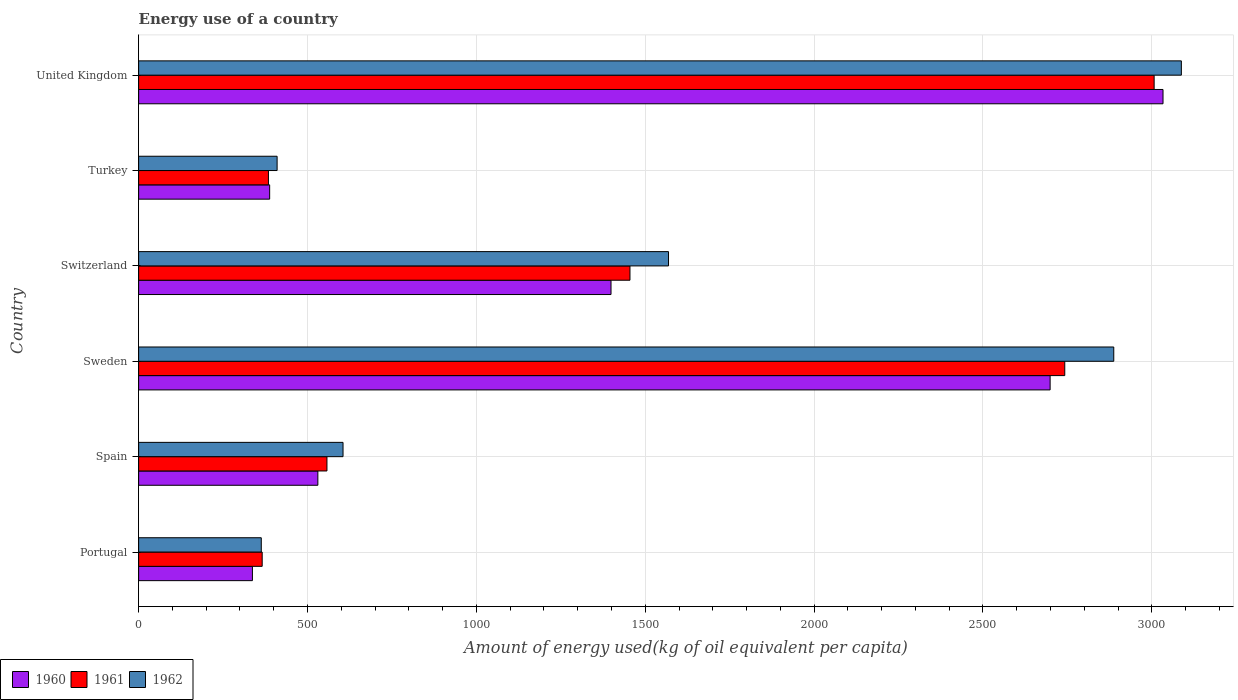How many different coloured bars are there?
Provide a succinct answer. 3. Are the number of bars per tick equal to the number of legend labels?
Provide a short and direct response. Yes. How many bars are there on the 3rd tick from the top?
Your response must be concise. 3. What is the label of the 3rd group of bars from the top?
Ensure brevity in your answer.  Switzerland. What is the amount of energy used in in 1960 in Sweden?
Ensure brevity in your answer.  2698.79. Across all countries, what is the maximum amount of energy used in in 1960?
Make the answer very short. 3033.05. Across all countries, what is the minimum amount of energy used in in 1962?
Give a very brief answer. 363.16. In which country was the amount of energy used in in 1961 maximum?
Your answer should be very brief. United Kingdom. What is the total amount of energy used in in 1961 in the graph?
Offer a terse response. 8511.41. What is the difference between the amount of energy used in in 1960 in Spain and that in Turkey?
Make the answer very short. 142.69. What is the difference between the amount of energy used in in 1961 in Spain and the amount of energy used in in 1962 in Portugal?
Offer a terse response. 194.44. What is the average amount of energy used in in 1962 per country?
Your answer should be very brief. 1486.98. What is the difference between the amount of energy used in in 1960 and amount of energy used in in 1961 in Turkey?
Keep it short and to the point. 3.62. In how many countries, is the amount of energy used in in 1960 greater than 2200 kg?
Your response must be concise. 2. What is the ratio of the amount of energy used in in 1962 in Portugal to that in United Kingdom?
Ensure brevity in your answer.  0.12. What is the difference between the highest and the second highest amount of energy used in in 1960?
Make the answer very short. 334.26. What is the difference between the highest and the lowest amount of energy used in in 1962?
Offer a very short reply. 2724.18. Is the sum of the amount of energy used in in 1960 in Switzerland and Turkey greater than the maximum amount of energy used in in 1962 across all countries?
Your response must be concise. No. What does the 3rd bar from the top in Turkey represents?
Your answer should be compact. 1960. What does the 1st bar from the bottom in United Kingdom represents?
Keep it short and to the point. 1960. Is it the case that in every country, the sum of the amount of energy used in in 1962 and amount of energy used in in 1960 is greater than the amount of energy used in in 1961?
Ensure brevity in your answer.  Yes. Are all the bars in the graph horizontal?
Keep it short and to the point. Yes. How many countries are there in the graph?
Keep it short and to the point. 6. What is the difference between two consecutive major ticks on the X-axis?
Provide a short and direct response. 500. Does the graph contain grids?
Your answer should be compact. Yes. Where does the legend appear in the graph?
Make the answer very short. Bottom left. How many legend labels are there?
Keep it short and to the point. 3. How are the legend labels stacked?
Offer a very short reply. Horizontal. What is the title of the graph?
Your answer should be compact. Energy use of a country. What is the label or title of the X-axis?
Your response must be concise. Amount of energy used(kg of oil equivalent per capita). What is the label or title of the Y-axis?
Make the answer very short. Country. What is the Amount of energy used(kg of oil equivalent per capita) of 1960 in Portugal?
Your response must be concise. 336.91. What is the Amount of energy used(kg of oil equivalent per capita) in 1961 in Portugal?
Your answer should be very brief. 365.84. What is the Amount of energy used(kg of oil equivalent per capita) in 1962 in Portugal?
Provide a succinct answer. 363.16. What is the Amount of energy used(kg of oil equivalent per capita) of 1960 in Spain?
Make the answer very short. 530.66. What is the Amount of energy used(kg of oil equivalent per capita) in 1961 in Spain?
Give a very brief answer. 557.6. What is the Amount of energy used(kg of oil equivalent per capita) of 1962 in Spain?
Give a very brief answer. 605.22. What is the Amount of energy used(kg of oil equivalent per capita) of 1960 in Sweden?
Your answer should be compact. 2698.79. What is the Amount of energy used(kg of oil equivalent per capita) of 1961 in Sweden?
Your answer should be very brief. 2742.12. What is the Amount of energy used(kg of oil equivalent per capita) of 1962 in Sweden?
Provide a short and direct response. 2887.24. What is the Amount of energy used(kg of oil equivalent per capita) of 1960 in Switzerland?
Give a very brief answer. 1398.65. What is the Amount of energy used(kg of oil equivalent per capita) of 1961 in Switzerland?
Offer a very short reply. 1454.76. What is the Amount of energy used(kg of oil equivalent per capita) of 1962 in Switzerland?
Give a very brief answer. 1568.91. What is the Amount of energy used(kg of oil equivalent per capita) of 1960 in Turkey?
Make the answer very short. 387.97. What is the Amount of energy used(kg of oil equivalent per capita) in 1961 in Turkey?
Make the answer very short. 384.35. What is the Amount of energy used(kg of oil equivalent per capita) of 1962 in Turkey?
Offer a very short reply. 410.02. What is the Amount of energy used(kg of oil equivalent per capita) in 1960 in United Kingdom?
Your answer should be compact. 3033.05. What is the Amount of energy used(kg of oil equivalent per capita) of 1961 in United Kingdom?
Provide a short and direct response. 3006.75. What is the Amount of energy used(kg of oil equivalent per capita) of 1962 in United Kingdom?
Make the answer very short. 3087.34. Across all countries, what is the maximum Amount of energy used(kg of oil equivalent per capita) of 1960?
Your response must be concise. 3033.05. Across all countries, what is the maximum Amount of energy used(kg of oil equivalent per capita) of 1961?
Give a very brief answer. 3006.75. Across all countries, what is the maximum Amount of energy used(kg of oil equivalent per capita) of 1962?
Your answer should be compact. 3087.34. Across all countries, what is the minimum Amount of energy used(kg of oil equivalent per capita) of 1960?
Provide a succinct answer. 336.91. Across all countries, what is the minimum Amount of energy used(kg of oil equivalent per capita) in 1961?
Offer a terse response. 365.84. Across all countries, what is the minimum Amount of energy used(kg of oil equivalent per capita) of 1962?
Offer a terse response. 363.16. What is the total Amount of energy used(kg of oil equivalent per capita) of 1960 in the graph?
Your answer should be compact. 8386.05. What is the total Amount of energy used(kg of oil equivalent per capita) of 1961 in the graph?
Ensure brevity in your answer.  8511.41. What is the total Amount of energy used(kg of oil equivalent per capita) of 1962 in the graph?
Your answer should be very brief. 8921.9. What is the difference between the Amount of energy used(kg of oil equivalent per capita) of 1960 in Portugal and that in Spain?
Give a very brief answer. -193.75. What is the difference between the Amount of energy used(kg of oil equivalent per capita) in 1961 in Portugal and that in Spain?
Keep it short and to the point. -191.76. What is the difference between the Amount of energy used(kg of oil equivalent per capita) of 1962 in Portugal and that in Spain?
Provide a short and direct response. -242.06. What is the difference between the Amount of energy used(kg of oil equivalent per capita) in 1960 in Portugal and that in Sweden?
Your answer should be compact. -2361.88. What is the difference between the Amount of energy used(kg of oil equivalent per capita) in 1961 in Portugal and that in Sweden?
Offer a very short reply. -2376.28. What is the difference between the Amount of energy used(kg of oil equivalent per capita) in 1962 in Portugal and that in Sweden?
Give a very brief answer. -2524.07. What is the difference between the Amount of energy used(kg of oil equivalent per capita) of 1960 in Portugal and that in Switzerland?
Your response must be concise. -1061.74. What is the difference between the Amount of energy used(kg of oil equivalent per capita) in 1961 in Portugal and that in Switzerland?
Give a very brief answer. -1088.91. What is the difference between the Amount of energy used(kg of oil equivalent per capita) in 1962 in Portugal and that in Switzerland?
Give a very brief answer. -1205.75. What is the difference between the Amount of energy used(kg of oil equivalent per capita) in 1960 in Portugal and that in Turkey?
Provide a short and direct response. -51.06. What is the difference between the Amount of energy used(kg of oil equivalent per capita) of 1961 in Portugal and that in Turkey?
Ensure brevity in your answer.  -18.51. What is the difference between the Amount of energy used(kg of oil equivalent per capita) of 1962 in Portugal and that in Turkey?
Provide a succinct answer. -46.86. What is the difference between the Amount of energy used(kg of oil equivalent per capita) of 1960 in Portugal and that in United Kingdom?
Give a very brief answer. -2696.14. What is the difference between the Amount of energy used(kg of oil equivalent per capita) of 1961 in Portugal and that in United Kingdom?
Provide a succinct answer. -2640.91. What is the difference between the Amount of energy used(kg of oil equivalent per capita) of 1962 in Portugal and that in United Kingdom?
Offer a terse response. -2724.18. What is the difference between the Amount of energy used(kg of oil equivalent per capita) in 1960 in Spain and that in Sweden?
Ensure brevity in your answer.  -2168.13. What is the difference between the Amount of energy used(kg of oil equivalent per capita) of 1961 in Spain and that in Sweden?
Make the answer very short. -2184.52. What is the difference between the Amount of energy used(kg of oil equivalent per capita) in 1962 in Spain and that in Sweden?
Ensure brevity in your answer.  -2282.01. What is the difference between the Amount of energy used(kg of oil equivalent per capita) of 1960 in Spain and that in Switzerland?
Your response must be concise. -867.99. What is the difference between the Amount of energy used(kg of oil equivalent per capita) in 1961 in Spain and that in Switzerland?
Provide a succinct answer. -897.16. What is the difference between the Amount of energy used(kg of oil equivalent per capita) of 1962 in Spain and that in Switzerland?
Offer a very short reply. -963.69. What is the difference between the Amount of energy used(kg of oil equivalent per capita) in 1960 in Spain and that in Turkey?
Ensure brevity in your answer.  142.69. What is the difference between the Amount of energy used(kg of oil equivalent per capita) of 1961 in Spain and that in Turkey?
Ensure brevity in your answer.  173.25. What is the difference between the Amount of energy used(kg of oil equivalent per capita) of 1962 in Spain and that in Turkey?
Provide a succinct answer. 195.2. What is the difference between the Amount of energy used(kg of oil equivalent per capita) of 1960 in Spain and that in United Kingdom?
Make the answer very short. -2502.39. What is the difference between the Amount of energy used(kg of oil equivalent per capita) in 1961 in Spain and that in United Kingdom?
Keep it short and to the point. -2449.15. What is the difference between the Amount of energy used(kg of oil equivalent per capita) in 1962 in Spain and that in United Kingdom?
Ensure brevity in your answer.  -2482.12. What is the difference between the Amount of energy used(kg of oil equivalent per capita) of 1960 in Sweden and that in Switzerland?
Give a very brief answer. 1300.14. What is the difference between the Amount of energy used(kg of oil equivalent per capita) in 1961 in Sweden and that in Switzerland?
Your response must be concise. 1287.37. What is the difference between the Amount of energy used(kg of oil equivalent per capita) of 1962 in Sweden and that in Switzerland?
Offer a very short reply. 1318.33. What is the difference between the Amount of energy used(kg of oil equivalent per capita) of 1960 in Sweden and that in Turkey?
Your response must be concise. 2310.82. What is the difference between the Amount of energy used(kg of oil equivalent per capita) of 1961 in Sweden and that in Turkey?
Provide a succinct answer. 2357.78. What is the difference between the Amount of energy used(kg of oil equivalent per capita) of 1962 in Sweden and that in Turkey?
Your answer should be very brief. 2477.21. What is the difference between the Amount of energy used(kg of oil equivalent per capita) in 1960 in Sweden and that in United Kingdom?
Offer a very short reply. -334.26. What is the difference between the Amount of energy used(kg of oil equivalent per capita) of 1961 in Sweden and that in United Kingdom?
Provide a short and direct response. -264.62. What is the difference between the Amount of energy used(kg of oil equivalent per capita) in 1962 in Sweden and that in United Kingdom?
Offer a very short reply. -200.11. What is the difference between the Amount of energy used(kg of oil equivalent per capita) of 1960 in Switzerland and that in Turkey?
Your answer should be compact. 1010.68. What is the difference between the Amount of energy used(kg of oil equivalent per capita) in 1961 in Switzerland and that in Turkey?
Offer a terse response. 1070.41. What is the difference between the Amount of energy used(kg of oil equivalent per capita) in 1962 in Switzerland and that in Turkey?
Your answer should be very brief. 1158.89. What is the difference between the Amount of energy used(kg of oil equivalent per capita) of 1960 in Switzerland and that in United Kingdom?
Your answer should be compact. -1634.4. What is the difference between the Amount of energy used(kg of oil equivalent per capita) in 1961 in Switzerland and that in United Kingdom?
Ensure brevity in your answer.  -1551.99. What is the difference between the Amount of energy used(kg of oil equivalent per capita) of 1962 in Switzerland and that in United Kingdom?
Offer a terse response. -1518.43. What is the difference between the Amount of energy used(kg of oil equivalent per capita) of 1960 in Turkey and that in United Kingdom?
Offer a very short reply. -2645.08. What is the difference between the Amount of energy used(kg of oil equivalent per capita) of 1961 in Turkey and that in United Kingdom?
Make the answer very short. -2622.4. What is the difference between the Amount of energy used(kg of oil equivalent per capita) of 1962 in Turkey and that in United Kingdom?
Give a very brief answer. -2677.32. What is the difference between the Amount of energy used(kg of oil equivalent per capita) in 1960 in Portugal and the Amount of energy used(kg of oil equivalent per capita) in 1961 in Spain?
Offer a very short reply. -220.69. What is the difference between the Amount of energy used(kg of oil equivalent per capita) in 1960 in Portugal and the Amount of energy used(kg of oil equivalent per capita) in 1962 in Spain?
Make the answer very short. -268.31. What is the difference between the Amount of energy used(kg of oil equivalent per capita) of 1961 in Portugal and the Amount of energy used(kg of oil equivalent per capita) of 1962 in Spain?
Ensure brevity in your answer.  -239.38. What is the difference between the Amount of energy used(kg of oil equivalent per capita) of 1960 in Portugal and the Amount of energy used(kg of oil equivalent per capita) of 1961 in Sweden?
Your answer should be compact. -2405.21. What is the difference between the Amount of energy used(kg of oil equivalent per capita) in 1960 in Portugal and the Amount of energy used(kg of oil equivalent per capita) in 1962 in Sweden?
Offer a terse response. -2550.32. What is the difference between the Amount of energy used(kg of oil equivalent per capita) of 1961 in Portugal and the Amount of energy used(kg of oil equivalent per capita) of 1962 in Sweden?
Give a very brief answer. -2521.4. What is the difference between the Amount of energy used(kg of oil equivalent per capita) of 1960 in Portugal and the Amount of energy used(kg of oil equivalent per capita) of 1961 in Switzerland?
Make the answer very short. -1117.84. What is the difference between the Amount of energy used(kg of oil equivalent per capita) of 1960 in Portugal and the Amount of energy used(kg of oil equivalent per capita) of 1962 in Switzerland?
Provide a short and direct response. -1232. What is the difference between the Amount of energy used(kg of oil equivalent per capita) of 1961 in Portugal and the Amount of energy used(kg of oil equivalent per capita) of 1962 in Switzerland?
Keep it short and to the point. -1203.07. What is the difference between the Amount of energy used(kg of oil equivalent per capita) in 1960 in Portugal and the Amount of energy used(kg of oil equivalent per capita) in 1961 in Turkey?
Provide a succinct answer. -47.43. What is the difference between the Amount of energy used(kg of oil equivalent per capita) in 1960 in Portugal and the Amount of energy used(kg of oil equivalent per capita) in 1962 in Turkey?
Your response must be concise. -73.11. What is the difference between the Amount of energy used(kg of oil equivalent per capita) in 1961 in Portugal and the Amount of energy used(kg of oil equivalent per capita) in 1962 in Turkey?
Your response must be concise. -44.18. What is the difference between the Amount of energy used(kg of oil equivalent per capita) in 1960 in Portugal and the Amount of energy used(kg of oil equivalent per capita) in 1961 in United Kingdom?
Give a very brief answer. -2669.83. What is the difference between the Amount of energy used(kg of oil equivalent per capita) in 1960 in Portugal and the Amount of energy used(kg of oil equivalent per capita) in 1962 in United Kingdom?
Provide a succinct answer. -2750.43. What is the difference between the Amount of energy used(kg of oil equivalent per capita) of 1961 in Portugal and the Amount of energy used(kg of oil equivalent per capita) of 1962 in United Kingdom?
Provide a succinct answer. -2721.5. What is the difference between the Amount of energy used(kg of oil equivalent per capita) of 1960 in Spain and the Amount of energy used(kg of oil equivalent per capita) of 1961 in Sweden?
Keep it short and to the point. -2211.46. What is the difference between the Amount of energy used(kg of oil equivalent per capita) of 1960 in Spain and the Amount of energy used(kg of oil equivalent per capita) of 1962 in Sweden?
Ensure brevity in your answer.  -2356.57. What is the difference between the Amount of energy used(kg of oil equivalent per capita) in 1961 in Spain and the Amount of energy used(kg of oil equivalent per capita) in 1962 in Sweden?
Your answer should be compact. -2329.64. What is the difference between the Amount of energy used(kg of oil equivalent per capita) in 1960 in Spain and the Amount of energy used(kg of oil equivalent per capita) in 1961 in Switzerland?
Keep it short and to the point. -924.09. What is the difference between the Amount of energy used(kg of oil equivalent per capita) of 1960 in Spain and the Amount of energy used(kg of oil equivalent per capita) of 1962 in Switzerland?
Offer a very short reply. -1038.25. What is the difference between the Amount of energy used(kg of oil equivalent per capita) in 1961 in Spain and the Amount of energy used(kg of oil equivalent per capita) in 1962 in Switzerland?
Your answer should be compact. -1011.31. What is the difference between the Amount of energy used(kg of oil equivalent per capita) in 1960 in Spain and the Amount of energy used(kg of oil equivalent per capita) in 1961 in Turkey?
Give a very brief answer. 146.32. What is the difference between the Amount of energy used(kg of oil equivalent per capita) of 1960 in Spain and the Amount of energy used(kg of oil equivalent per capita) of 1962 in Turkey?
Your answer should be compact. 120.64. What is the difference between the Amount of energy used(kg of oil equivalent per capita) of 1961 in Spain and the Amount of energy used(kg of oil equivalent per capita) of 1962 in Turkey?
Provide a succinct answer. 147.58. What is the difference between the Amount of energy used(kg of oil equivalent per capita) in 1960 in Spain and the Amount of energy used(kg of oil equivalent per capita) in 1961 in United Kingdom?
Ensure brevity in your answer.  -2476.08. What is the difference between the Amount of energy used(kg of oil equivalent per capita) in 1960 in Spain and the Amount of energy used(kg of oil equivalent per capita) in 1962 in United Kingdom?
Your response must be concise. -2556.68. What is the difference between the Amount of energy used(kg of oil equivalent per capita) in 1961 in Spain and the Amount of energy used(kg of oil equivalent per capita) in 1962 in United Kingdom?
Your answer should be compact. -2529.74. What is the difference between the Amount of energy used(kg of oil equivalent per capita) in 1960 in Sweden and the Amount of energy used(kg of oil equivalent per capita) in 1961 in Switzerland?
Provide a succinct answer. 1244.04. What is the difference between the Amount of energy used(kg of oil equivalent per capita) in 1960 in Sweden and the Amount of energy used(kg of oil equivalent per capita) in 1962 in Switzerland?
Provide a short and direct response. 1129.88. What is the difference between the Amount of energy used(kg of oil equivalent per capita) of 1961 in Sweden and the Amount of energy used(kg of oil equivalent per capita) of 1962 in Switzerland?
Your response must be concise. 1173.21. What is the difference between the Amount of energy used(kg of oil equivalent per capita) in 1960 in Sweden and the Amount of energy used(kg of oil equivalent per capita) in 1961 in Turkey?
Offer a very short reply. 2314.45. What is the difference between the Amount of energy used(kg of oil equivalent per capita) of 1960 in Sweden and the Amount of energy used(kg of oil equivalent per capita) of 1962 in Turkey?
Give a very brief answer. 2288.77. What is the difference between the Amount of energy used(kg of oil equivalent per capita) in 1961 in Sweden and the Amount of energy used(kg of oil equivalent per capita) in 1962 in Turkey?
Keep it short and to the point. 2332.1. What is the difference between the Amount of energy used(kg of oil equivalent per capita) of 1960 in Sweden and the Amount of energy used(kg of oil equivalent per capita) of 1961 in United Kingdom?
Ensure brevity in your answer.  -307.96. What is the difference between the Amount of energy used(kg of oil equivalent per capita) in 1960 in Sweden and the Amount of energy used(kg of oil equivalent per capita) in 1962 in United Kingdom?
Make the answer very short. -388.55. What is the difference between the Amount of energy used(kg of oil equivalent per capita) in 1961 in Sweden and the Amount of energy used(kg of oil equivalent per capita) in 1962 in United Kingdom?
Make the answer very short. -345.22. What is the difference between the Amount of energy used(kg of oil equivalent per capita) of 1960 in Switzerland and the Amount of energy used(kg of oil equivalent per capita) of 1961 in Turkey?
Make the answer very short. 1014.31. What is the difference between the Amount of energy used(kg of oil equivalent per capita) of 1960 in Switzerland and the Amount of energy used(kg of oil equivalent per capita) of 1962 in Turkey?
Give a very brief answer. 988.63. What is the difference between the Amount of energy used(kg of oil equivalent per capita) of 1961 in Switzerland and the Amount of energy used(kg of oil equivalent per capita) of 1962 in Turkey?
Your answer should be compact. 1044.73. What is the difference between the Amount of energy used(kg of oil equivalent per capita) in 1960 in Switzerland and the Amount of energy used(kg of oil equivalent per capita) in 1961 in United Kingdom?
Keep it short and to the point. -1608.09. What is the difference between the Amount of energy used(kg of oil equivalent per capita) in 1960 in Switzerland and the Amount of energy used(kg of oil equivalent per capita) in 1962 in United Kingdom?
Keep it short and to the point. -1688.69. What is the difference between the Amount of energy used(kg of oil equivalent per capita) in 1961 in Switzerland and the Amount of energy used(kg of oil equivalent per capita) in 1962 in United Kingdom?
Offer a very short reply. -1632.59. What is the difference between the Amount of energy used(kg of oil equivalent per capita) of 1960 in Turkey and the Amount of energy used(kg of oil equivalent per capita) of 1961 in United Kingdom?
Ensure brevity in your answer.  -2618.78. What is the difference between the Amount of energy used(kg of oil equivalent per capita) in 1960 in Turkey and the Amount of energy used(kg of oil equivalent per capita) in 1962 in United Kingdom?
Make the answer very short. -2699.37. What is the difference between the Amount of energy used(kg of oil equivalent per capita) in 1961 in Turkey and the Amount of energy used(kg of oil equivalent per capita) in 1962 in United Kingdom?
Offer a very short reply. -2703. What is the average Amount of energy used(kg of oil equivalent per capita) of 1960 per country?
Provide a succinct answer. 1397.67. What is the average Amount of energy used(kg of oil equivalent per capita) in 1961 per country?
Make the answer very short. 1418.57. What is the average Amount of energy used(kg of oil equivalent per capita) in 1962 per country?
Provide a short and direct response. 1486.98. What is the difference between the Amount of energy used(kg of oil equivalent per capita) in 1960 and Amount of energy used(kg of oil equivalent per capita) in 1961 in Portugal?
Your answer should be compact. -28.93. What is the difference between the Amount of energy used(kg of oil equivalent per capita) in 1960 and Amount of energy used(kg of oil equivalent per capita) in 1962 in Portugal?
Provide a short and direct response. -26.25. What is the difference between the Amount of energy used(kg of oil equivalent per capita) in 1961 and Amount of energy used(kg of oil equivalent per capita) in 1962 in Portugal?
Give a very brief answer. 2.68. What is the difference between the Amount of energy used(kg of oil equivalent per capita) of 1960 and Amount of energy used(kg of oil equivalent per capita) of 1961 in Spain?
Provide a succinct answer. -26.93. What is the difference between the Amount of energy used(kg of oil equivalent per capita) in 1960 and Amount of energy used(kg of oil equivalent per capita) in 1962 in Spain?
Provide a short and direct response. -74.56. What is the difference between the Amount of energy used(kg of oil equivalent per capita) in 1961 and Amount of energy used(kg of oil equivalent per capita) in 1962 in Spain?
Ensure brevity in your answer.  -47.62. What is the difference between the Amount of energy used(kg of oil equivalent per capita) in 1960 and Amount of energy used(kg of oil equivalent per capita) in 1961 in Sweden?
Offer a very short reply. -43.33. What is the difference between the Amount of energy used(kg of oil equivalent per capita) in 1960 and Amount of energy used(kg of oil equivalent per capita) in 1962 in Sweden?
Give a very brief answer. -188.44. What is the difference between the Amount of energy used(kg of oil equivalent per capita) in 1961 and Amount of energy used(kg of oil equivalent per capita) in 1962 in Sweden?
Provide a succinct answer. -145.11. What is the difference between the Amount of energy used(kg of oil equivalent per capita) in 1960 and Amount of energy used(kg of oil equivalent per capita) in 1961 in Switzerland?
Provide a short and direct response. -56.1. What is the difference between the Amount of energy used(kg of oil equivalent per capita) in 1960 and Amount of energy used(kg of oil equivalent per capita) in 1962 in Switzerland?
Offer a very short reply. -170.26. What is the difference between the Amount of energy used(kg of oil equivalent per capita) in 1961 and Amount of energy used(kg of oil equivalent per capita) in 1962 in Switzerland?
Keep it short and to the point. -114.16. What is the difference between the Amount of energy used(kg of oil equivalent per capita) of 1960 and Amount of energy used(kg of oil equivalent per capita) of 1961 in Turkey?
Ensure brevity in your answer.  3.62. What is the difference between the Amount of energy used(kg of oil equivalent per capita) of 1960 and Amount of energy used(kg of oil equivalent per capita) of 1962 in Turkey?
Your answer should be very brief. -22.05. What is the difference between the Amount of energy used(kg of oil equivalent per capita) of 1961 and Amount of energy used(kg of oil equivalent per capita) of 1962 in Turkey?
Your answer should be compact. -25.68. What is the difference between the Amount of energy used(kg of oil equivalent per capita) in 1960 and Amount of energy used(kg of oil equivalent per capita) in 1961 in United Kingdom?
Offer a terse response. 26.3. What is the difference between the Amount of energy used(kg of oil equivalent per capita) of 1960 and Amount of energy used(kg of oil equivalent per capita) of 1962 in United Kingdom?
Ensure brevity in your answer.  -54.29. What is the difference between the Amount of energy used(kg of oil equivalent per capita) in 1961 and Amount of energy used(kg of oil equivalent per capita) in 1962 in United Kingdom?
Keep it short and to the point. -80.59. What is the ratio of the Amount of energy used(kg of oil equivalent per capita) in 1960 in Portugal to that in Spain?
Provide a succinct answer. 0.63. What is the ratio of the Amount of energy used(kg of oil equivalent per capita) in 1961 in Portugal to that in Spain?
Your answer should be compact. 0.66. What is the ratio of the Amount of energy used(kg of oil equivalent per capita) of 1962 in Portugal to that in Spain?
Make the answer very short. 0.6. What is the ratio of the Amount of energy used(kg of oil equivalent per capita) in 1960 in Portugal to that in Sweden?
Keep it short and to the point. 0.12. What is the ratio of the Amount of energy used(kg of oil equivalent per capita) of 1961 in Portugal to that in Sweden?
Make the answer very short. 0.13. What is the ratio of the Amount of energy used(kg of oil equivalent per capita) of 1962 in Portugal to that in Sweden?
Your answer should be very brief. 0.13. What is the ratio of the Amount of energy used(kg of oil equivalent per capita) of 1960 in Portugal to that in Switzerland?
Provide a short and direct response. 0.24. What is the ratio of the Amount of energy used(kg of oil equivalent per capita) of 1961 in Portugal to that in Switzerland?
Provide a succinct answer. 0.25. What is the ratio of the Amount of energy used(kg of oil equivalent per capita) of 1962 in Portugal to that in Switzerland?
Provide a short and direct response. 0.23. What is the ratio of the Amount of energy used(kg of oil equivalent per capita) in 1960 in Portugal to that in Turkey?
Your answer should be very brief. 0.87. What is the ratio of the Amount of energy used(kg of oil equivalent per capita) in 1961 in Portugal to that in Turkey?
Your answer should be compact. 0.95. What is the ratio of the Amount of energy used(kg of oil equivalent per capita) of 1962 in Portugal to that in Turkey?
Make the answer very short. 0.89. What is the ratio of the Amount of energy used(kg of oil equivalent per capita) of 1961 in Portugal to that in United Kingdom?
Provide a succinct answer. 0.12. What is the ratio of the Amount of energy used(kg of oil equivalent per capita) in 1962 in Portugal to that in United Kingdom?
Offer a terse response. 0.12. What is the ratio of the Amount of energy used(kg of oil equivalent per capita) of 1960 in Spain to that in Sweden?
Offer a very short reply. 0.2. What is the ratio of the Amount of energy used(kg of oil equivalent per capita) in 1961 in Spain to that in Sweden?
Your answer should be compact. 0.2. What is the ratio of the Amount of energy used(kg of oil equivalent per capita) in 1962 in Spain to that in Sweden?
Your answer should be compact. 0.21. What is the ratio of the Amount of energy used(kg of oil equivalent per capita) of 1960 in Spain to that in Switzerland?
Provide a short and direct response. 0.38. What is the ratio of the Amount of energy used(kg of oil equivalent per capita) of 1961 in Spain to that in Switzerland?
Keep it short and to the point. 0.38. What is the ratio of the Amount of energy used(kg of oil equivalent per capita) in 1962 in Spain to that in Switzerland?
Your answer should be compact. 0.39. What is the ratio of the Amount of energy used(kg of oil equivalent per capita) of 1960 in Spain to that in Turkey?
Offer a terse response. 1.37. What is the ratio of the Amount of energy used(kg of oil equivalent per capita) in 1961 in Spain to that in Turkey?
Provide a succinct answer. 1.45. What is the ratio of the Amount of energy used(kg of oil equivalent per capita) in 1962 in Spain to that in Turkey?
Your answer should be compact. 1.48. What is the ratio of the Amount of energy used(kg of oil equivalent per capita) of 1960 in Spain to that in United Kingdom?
Your answer should be very brief. 0.17. What is the ratio of the Amount of energy used(kg of oil equivalent per capita) of 1961 in Spain to that in United Kingdom?
Offer a terse response. 0.19. What is the ratio of the Amount of energy used(kg of oil equivalent per capita) in 1962 in Spain to that in United Kingdom?
Your answer should be compact. 0.2. What is the ratio of the Amount of energy used(kg of oil equivalent per capita) of 1960 in Sweden to that in Switzerland?
Provide a short and direct response. 1.93. What is the ratio of the Amount of energy used(kg of oil equivalent per capita) in 1961 in Sweden to that in Switzerland?
Provide a succinct answer. 1.88. What is the ratio of the Amount of energy used(kg of oil equivalent per capita) of 1962 in Sweden to that in Switzerland?
Make the answer very short. 1.84. What is the ratio of the Amount of energy used(kg of oil equivalent per capita) of 1960 in Sweden to that in Turkey?
Keep it short and to the point. 6.96. What is the ratio of the Amount of energy used(kg of oil equivalent per capita) in 1961 in Sweden to that in Turkey?
Your response must be concise. 7.13. What is the ratio of the Amount of energy used(kg of oil equivalent per capita) in 1962 in Sweden to that in Turkey?
Keep it short and to the point. 7.04. What is the ratio of the Amount of energy used(kg of oil equivalent per capita) in 1960 in Sweden to that in United Kingdom?
Keep it short and to the point. 0.89. What is the ratio of the Amount of energy used(kg of oil equivalent per capita) in 1961 in Sweden to that in United Kingdom?
Make the answer very short. 0.91. What is the ratio of the Amount of energy used(kg of oil equivalent per capita) of 1962 in Sweden to that in United Kingdom?
Ensure brevity in your answer.  0.94. What is the ratio of the Amount of energy used(kg of oil equivalent per capita) of 1960 in Switzerland to that in Turkey?
Your answer should be very brief. 3.61. What is the ratio of the Amount of energy used(kg of oil equivalent per capita) of 1961 in Switzerland to that in Turkey?
Your answer should be compact. 3.79. What is the ratio of the Amount of energy used(kg of oil equivalent per capita) of 1962 in Switzerland to that in Turkey?
Keep it short and to the point. 3.83. What is the ratio of the Amount of energy used(kg of oil equivalent per capita) in 1960 in Switzerland to that in United Kingdom?
Provide a short and direct response. 0.46. What is the ratio of the Amount of energy used(kg of oil equivalent per capita) in 1961 in Switzerland to that in United Kingdom?
Provide a short and direct response. 0.48. What is the ratio of the Amount of energy used(kg of oil equivalent per capita) of 1962 in Switzerland to that in United Kingdom?
Provide a succinct answer. 0.51. What is the ratio of the Amount of energy used(kg of oil equivalent per capita) in 1960 in Turkey to that in United Kingdom?
Offer a terse response. 0.13. What is the ratio of the Amount of energy used(kg of oil equivalent per capita) in 1961 in Turkey to that in United Kingdom?
Provide a short and direct response. 0.13. What is the ratio of the Amount of energy used(kg of oil equivalent per capita) of 1962 in Turkey to that in United Kingdom?
Offer a very short reply. 0.13. What is the difference between the highest and the second highest Amount of energy used(kg of oil equivalent per capita) in 1960?
Your response must be concise. 334.26. What is the difference between the highest and the second highest Amount of energy used(kg of oil equivalent per capita) of 1961?
Offer a very short reply. 264.62. What is the difference between the highest and the second highest Amount of energy used(kg of oil equivalent per capita) of 1962?
Make the answer very short. 200.11. What is the difference between the highest and the lowest Amount of energy used(kg of oil equivalent per capita) in 1960?
Offer a very short reply. 2696.14. What is the difference between the highest and the lowest Amount of energy used(kg of oil equivalent per capita) of 1961?
Give a very brief answer. 2640.91. What is the difference between the highest and the lowest Amount of energy used(kg of oil equivalent per capita) in 1962?
Keep it short and to the point. 2724.18. 